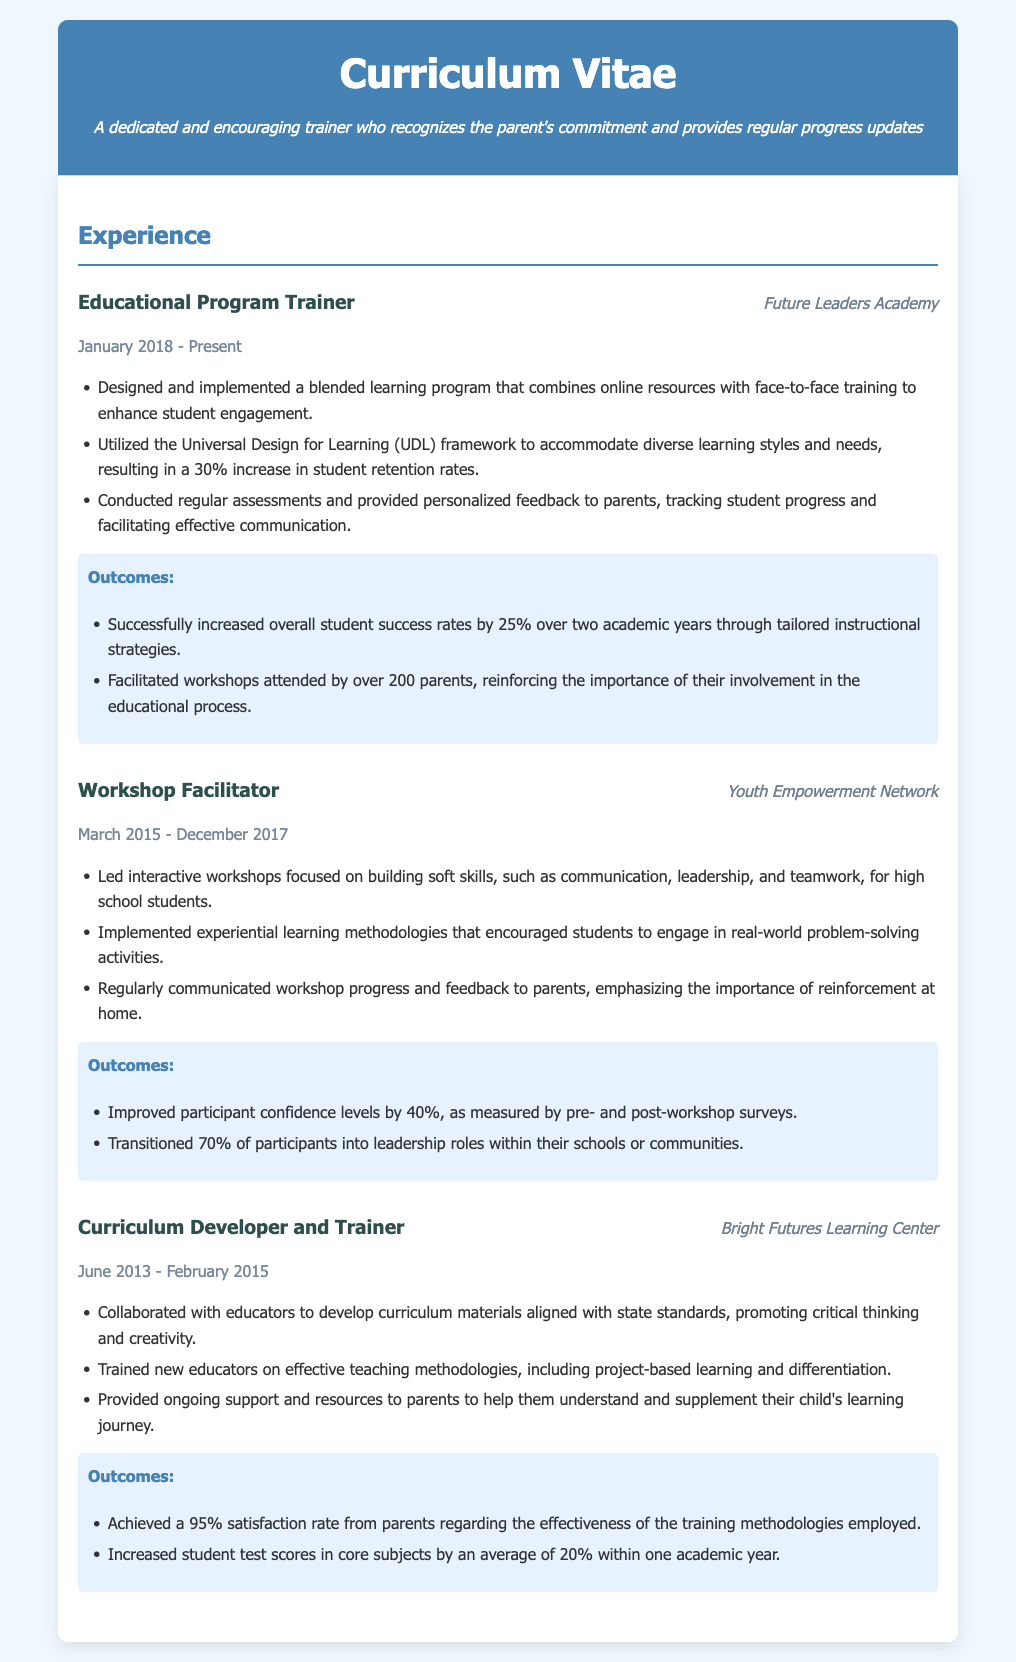What is the position held at Future Leaders Academy? The position held is listed under the Experience section, which specifies "Educational Program Trainer".
Answer: Educational Program Trainer What percentage increase in student retention rates resulted from the UDL framework? The document states a "30% increase in student retention rates" due to the implementation of the UDL framework.
Answer: 30% How many years did the individual work at Youth Empowerment Network? The date range from March 2015 to December 2017 indicates a total of nearly 3 years of work.
Answer: Nearly 3 years What was the improvement in participant confidence levels after the workshops? The outcomes section mentions "Improved participant confidence levels by 40%".
Answer: 40% What is the satisfaction rate from parents regarding the effectiveness of training methodologies at Bright Futures Learning Center? The document specifies a "95% satisfaction rate from parents".
Answer: 95% How many parents attended workshops at the Future Leaders Academy? The outcome mentions that "over 200 parents" attended workshops.
Answer: Over 200 parents Which teaching methodology was used in the curriculum development at Bright Futures Learning Center? The training methodologies included "project-based learning and differentiation."
Answer: Project-based learning and differentiation How much did student test scores increase on average within one academic year? The document states a "20% increase in student test scores in core subjects."
Answer: 20% 